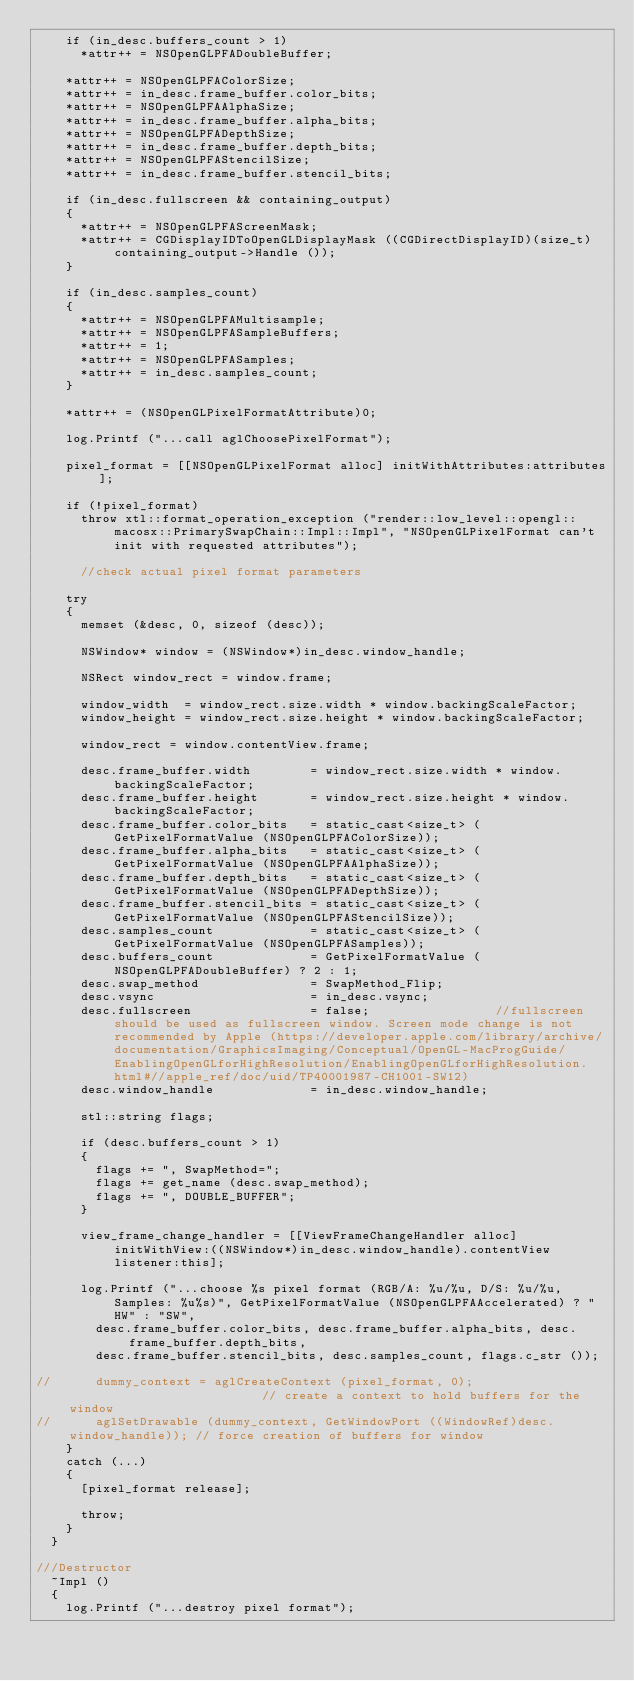Convert code to text. <code><loc_0><loc_0><loc_500><loc_500><_ObjectiveC_>    if (in_desc.buffers_count > 1)
      *attr++ = NSOpenGLPFADoubleBuffer;

    *attr++ = NSOpenGLPFAColorSize;
    *attr++ = in_desc.frame_buffer.color_bits;
    *attr++ = NSOpenGLPFAAlphaSize;
    *attr++ = in_desc.frame_buffer.alpha_bits;
    *attr++ = NSOpenGLPFADepthSize;
    *attr++ = in_desc.frame_buffer.depth_bits;
    *attr++ = NSOpenGLPFAStencilSize;
    *attr++ = in_desc.frame_buffer.stencil_bits;

    if (in_desc.fullscreen && containing_output)
    {
      *attr++ = NSOpenGLPFAScreenMask;
      *attr++ = CGDisplayIDToOpenGLDisplayMask ((CGDirectDisplayID)(size_t)containing_output->Handle ());
    }

    if (in_desc.samples_count)
    {
      *attr++ = NSOpenGLPFAMultisample;
      *attr++ = NSOpenGLPFASampleBuffers;
      *attr++ = 1;
      *attr++ = NSOpenGLPFASamples;
      *attr++ = in_desc.samples_count;
    }

    *attr++ = (NSOpenGLPixelFormatAttribute)0;

    log.Printf ("...call aglChoosePixelFormat");

    pixel_format = [[NSOpenGLPixelFormat alloc] initWithAttributes:attributes];

    if (!pixel_format)
      throw xtl::format_operation_exception ("render::low_level::opengl::macosx::PrimarySwapChain::Impl::Impl", "NSOpenGLPixelFormat can't init with requested attributes");

      //check actual pixel format parameters

    try
    {
      memset (&desc, 0, sizeof (desc));

      NSWindow* window = (NSWindow*)in_desc.window_handle;

      NSRect window_rect = window.frame;

      window_width  = window_rect.size.width * window.backingScaleFactor;
      window_height = window_rect.size.height * window.backingScaleFactor;

      window_rect = window.contentView.frame;

      desc.frame_buffer.width        = window_rect.size.width * window.backingScaleFactor;
      desc.frame_buffer.height       = window_rect.size.height * window.backingScaleFactor;
      desc.frame_buffer.color_bits   = static_cast<size_t> (GetPixelFormatValue (NSOpenGLPFAColorSize));
      desc.frame_buffer.alpha_bits   = static_cast<size_t> (GetPixelFormatValue (NSOpenGLPFAAlphaSize));
      desc.frame_buffer.depth_bits   = static_cast<size_t> (GetPixelFormatValue (NSOpenGLPFADepthSize));
      desc.frame_buffer.stencil_bits = static_cast<size_t> (GetPixelFormatValue (NSOpenGLPFAStencilSize));
      desc.samples_count             = static_cast<size_t> (GetPixelFormatValue (NSOpenGLPFASamples));
      desc.buffers_count             = GetPixelFormatValue (NSOpenGLPFADoubleBuffer) ? 2 : 1;
      desc.swap_method               = SwapMethod_Flip;
      desc.vsync                     = in_desc.vsync;
      desc.fullscreen                = false;                 //fullscreen should be used as fullscreen window. Screen mode change is not recommended by Apple (https://developer.apple.com/library/archive/documentation/GraphicsImaging/Conceptual/OpenGL-MacProgGuide/EnablingOpenGLforHighResolution/EnablingOpenGLforHighResolution.html#//apple_ref/doc/uid/TP40001987-CH1001-SW12)
      desc.window_handle             = in_desc.window_handle;

      stl::string flags;

      if (desc.buffers_count > 1)
      {
        flags += ", SwapMethod=";
        flags += get_name (desc.swap_method);
        flags += ", DOUBLE_BUFFER";
      }

      view_frame_change_handler = [[ViewFrameChangeHandler alloc] initWithView:((NSWindow*)in_desc.window_handle).contentView listener:this];

      log.Printf ("...choose %s pixel format (RGB/A: %u/%u, D/S: %u/%u, Samples: %u%s)", GetPixelFormatValue (NSOpenGLPFAAccelerated) ? "HW" : "SW",
        desc.frame_buffer.color_bits, desc.frame_buffer.alpha_bits, desc.frame_buffer.depth_bits,
        desc.frame_buffer.stencil_bits, desc.samples_count, flags.c_str ());

//      dummy_context = aglCreateContext (pixel_format, 0);                           // create a context to hold buffers for the window
//      aglSetDrawable (dummy_context, GetWindowPort ((WindowRef)desc.window_handle)); // force creation of buffers for window
    }
    catch (...)
    {
      [pixel_format release];

      throw;
    }
  }

///Destructor
  ~Impl ()
  {
    log.Printf ("...destroy pixel format");
</code> 